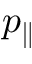<formula> <loc_0><loc_0><loc_500><loc_500>p _ { \| }</formula> 